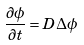Convert formula to latex. <formula><loc_0><loc_0><loc_500><loc_500>\frac { \partial \phi } { \partial t } = D \Delta \phi</formula> 